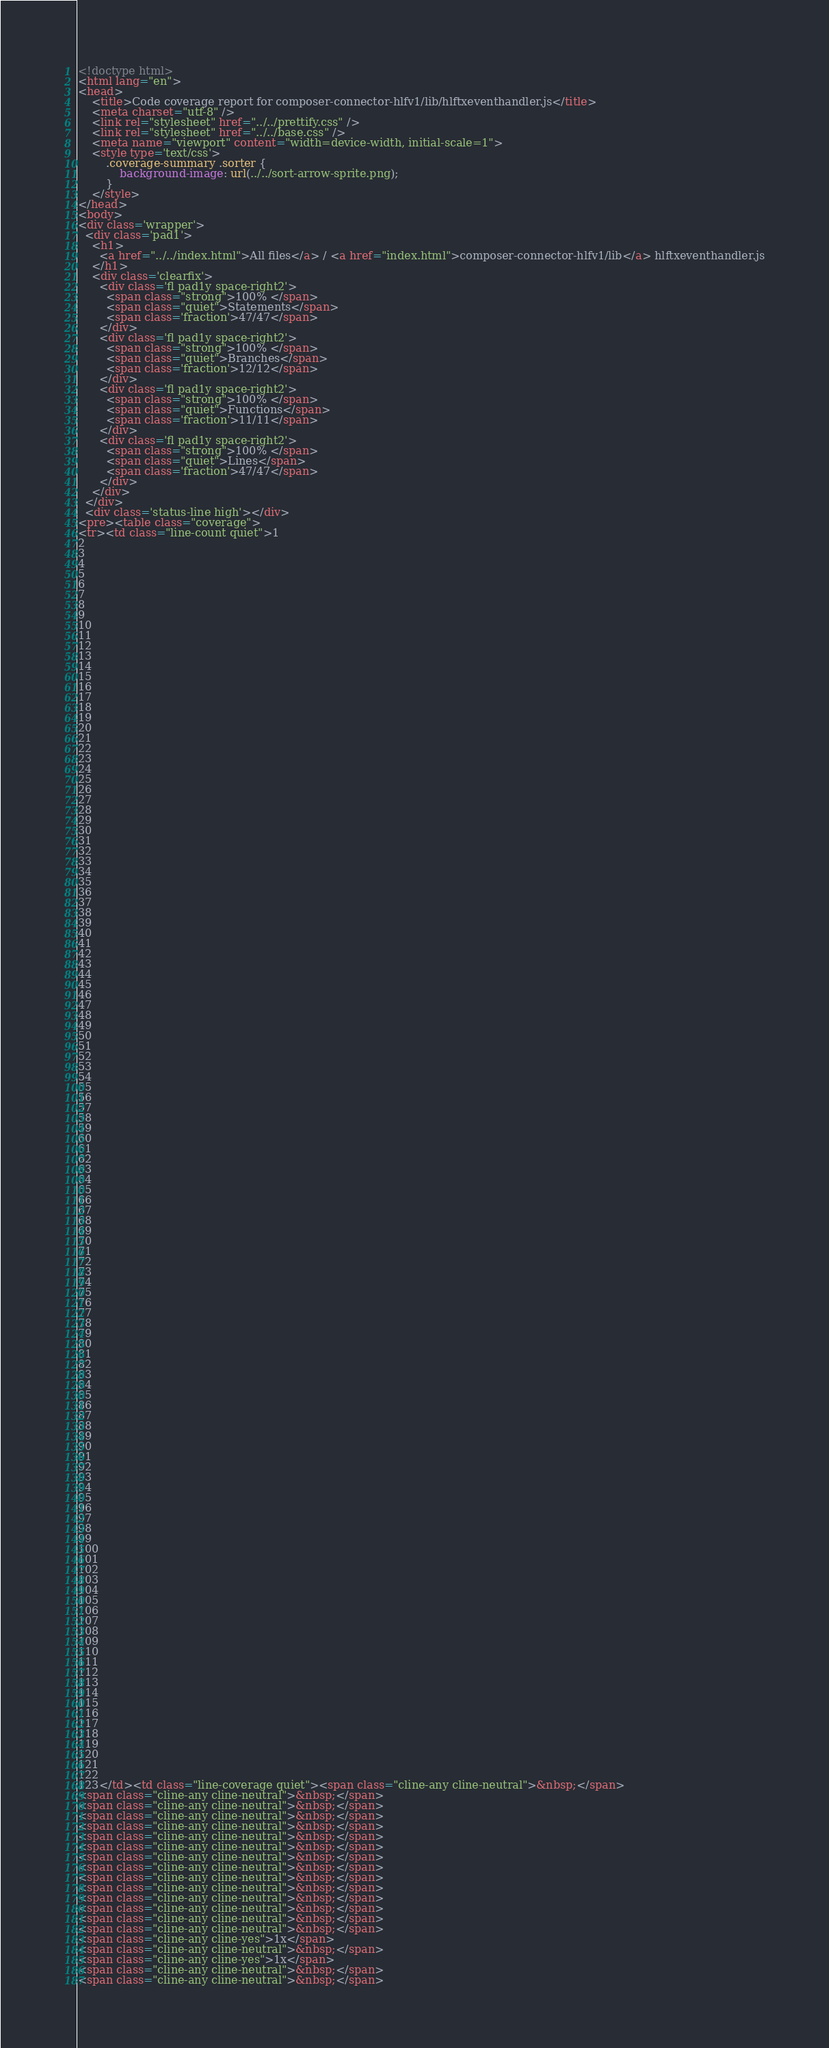<code> <loc_0><loc_0><loc_500><loc_500><_HTML_><!doctype html>
<html lang="en">
<head>
    <title>Code coverage report for composer-connector-hlfv1/lib/hlftxeventhandler.js</title>
    <meta charset="utf-8" />
    <link rel="stylesheet" href="../../prettify.css" />
    <link rel="stylesheet" href="../../base.css" />
    <meta name="viewport" content="width=device-width, initial-scale=1">
    <style type='text/css'>
        .coverage-summary .sorter {
            background-image: url(../../sort-arrow-sprite.png);
        }
    </style>
</head>
<body>
<div class='wrapper'>
  <div class='pad1'>
    <h1>
      <a href="../../index.html">All files</a> / <a href="index.html">composer-connector-hlfv1/lib</a> hlftxeventhandler.js
    </h1>
    <div class='clearfix'>
      <div class='fl pad1y space-right2'>
        <span class="strong">100% </span>
        <span class="quiet">Statements</span>
        <span class='fraction'>47/47</span>
      </div>
      <div class='fl pad1y space-right2'>
        <span class="strong">100% </span>
        <span class="quiet">Branches</span>
        <span class='fraction'>12/12</span>
      </div>
      <div class='fl pad1y space-right2'>
        <span class="strong">100% </span>
        <span class="quiet">Functions</span>
        <span class='fraction'>11/11</span>
      </div>
      <div class='fl pad1y space-right2'>
        <span class="strong">100% </span>
        <span class="quiet">Lines</span>
        <span class='fraction'>47/47</span>
      </div>
    </div>
  </div>
  <div class='status-line high'></div>
<pre><table class="coverage">
<tr><td class="line-count quiet">1
2
3
4
5
6
7
8
9
10
11
12
13
14
15
16
17
18
19
20
21
22
23
24
25
26
27
28
29
30
31
32
33
34
35
36
37
38
39
40
41
42
43
44
45
46
47
48
49
50
51
52
53
54
55
56
57
58
59
60
61
62
63
64
65
66
67
68
69
70
71
72
73
74
75
76
77
78
79
80
81
82
83
84
85
86
87
88
89
90
91
92
93
94
95
96
97
98
99
100
101
102
103
104
105
106
107
108
109
110
111
112
113
114
115
116
117
118
119
120
121
122
123</td><td class="line-coverage quiet"><span class="cline-any cline-neutral">&nbsp;</span>
<span class="cline-any cline-neutral">&nbsp;</span>
<span class="cline-any cline-neutral">&nbsp;</span>
<span class="cline-any cline-neutral">&nbsp;</span>
<span class="cline-any cline-neutral">&nbsp;</span>
<span class="cline-any cline-neutral">&nbsp;</span>
<span class="cline-any cline-neutral">&nbsp;</span>
<span class="cline-any cline-neutral">&nbsp;</span>
<span class="cline-any cline-neutral">&nbsp;</span>
<span class="cline-any cline-neutral">&nbsp;</span>
<span class="cline-any cline-neutral">&nbsp;</span>
<span class="cline-any cline-neutral">&nbsp;</span>
<span class="cline-any cline-neutral">&nbsp;</span>
<span class="cline-any cline-neutral">&nbsp;</span>
<span class="cline-any cline-neutral">&nbsp;</span>
<span class="cline-any cline-yes">1x</span>
<span class="cline-any cline-neutral">&nbsp;</span>
<span class="cline-any cline-yes">1x</span>
<span class="cline-any cline-neutral">&nbsp;</span>
<span class="cline-any cline-neutral">&nbsp;</span></code> 